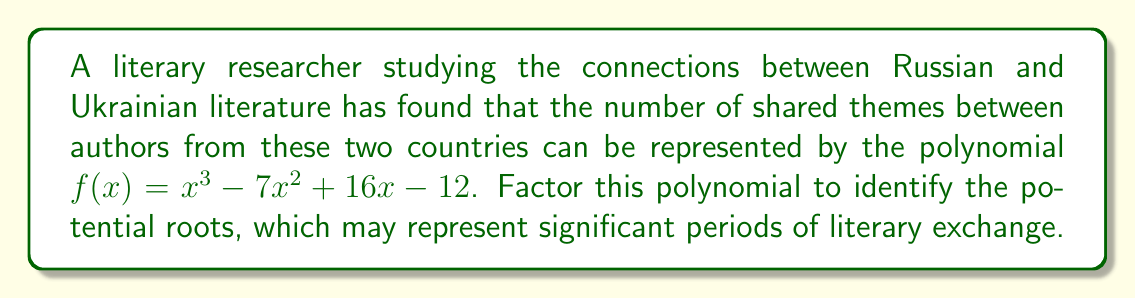Can you answer this question? To factor this polynomial, we'll follow these steps:

1) First, let's check if there are any rational roots using the rational root theorem. The possible rational roots are the factors of the constant term (12): ±1, ±2, ±3, ±4, ±6, ±12.

2) Testing these values, we find that f(1) = 0. So (x - 1) is a factor.

3) We can use polynomial long division to divide f(x) by (x - 1):

   $$ \frac{x^3 - 7x^2 + 16x - 12}{x - 1} = x^2 - 6x + 10 $$

4) So now we have: $f(x) = (x - 1)(x^2 - 6x + 10)$

5) The quadratic factor $x^2 - 6x + 10$ can be factored further using the quadratic formula or by recognizing it as a perfect square trinomial:

   $x^2 - 6x + 10 = (x - 3)^2 + 1$

6) This cannot be factored further over the real numbers.

Therefore, the final factorization is:

$f(x) = (x - 1)(x^2 - 6x + 10) = (x - 1)((x - 3)^2 + 1)$
Answer: $(x - 1)((x - 3)^2 + 1)$ 